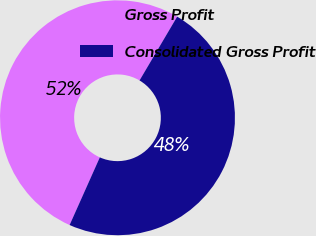Convert chart to OTSL. <chart><loc_0><loc_0><loc_500><loc_500><pie_chart><fcel>Gross Profit<fcel>Consolidated Gross Profit<nl><fcel>51.8%<fcel>48.2%<nl></chart> 